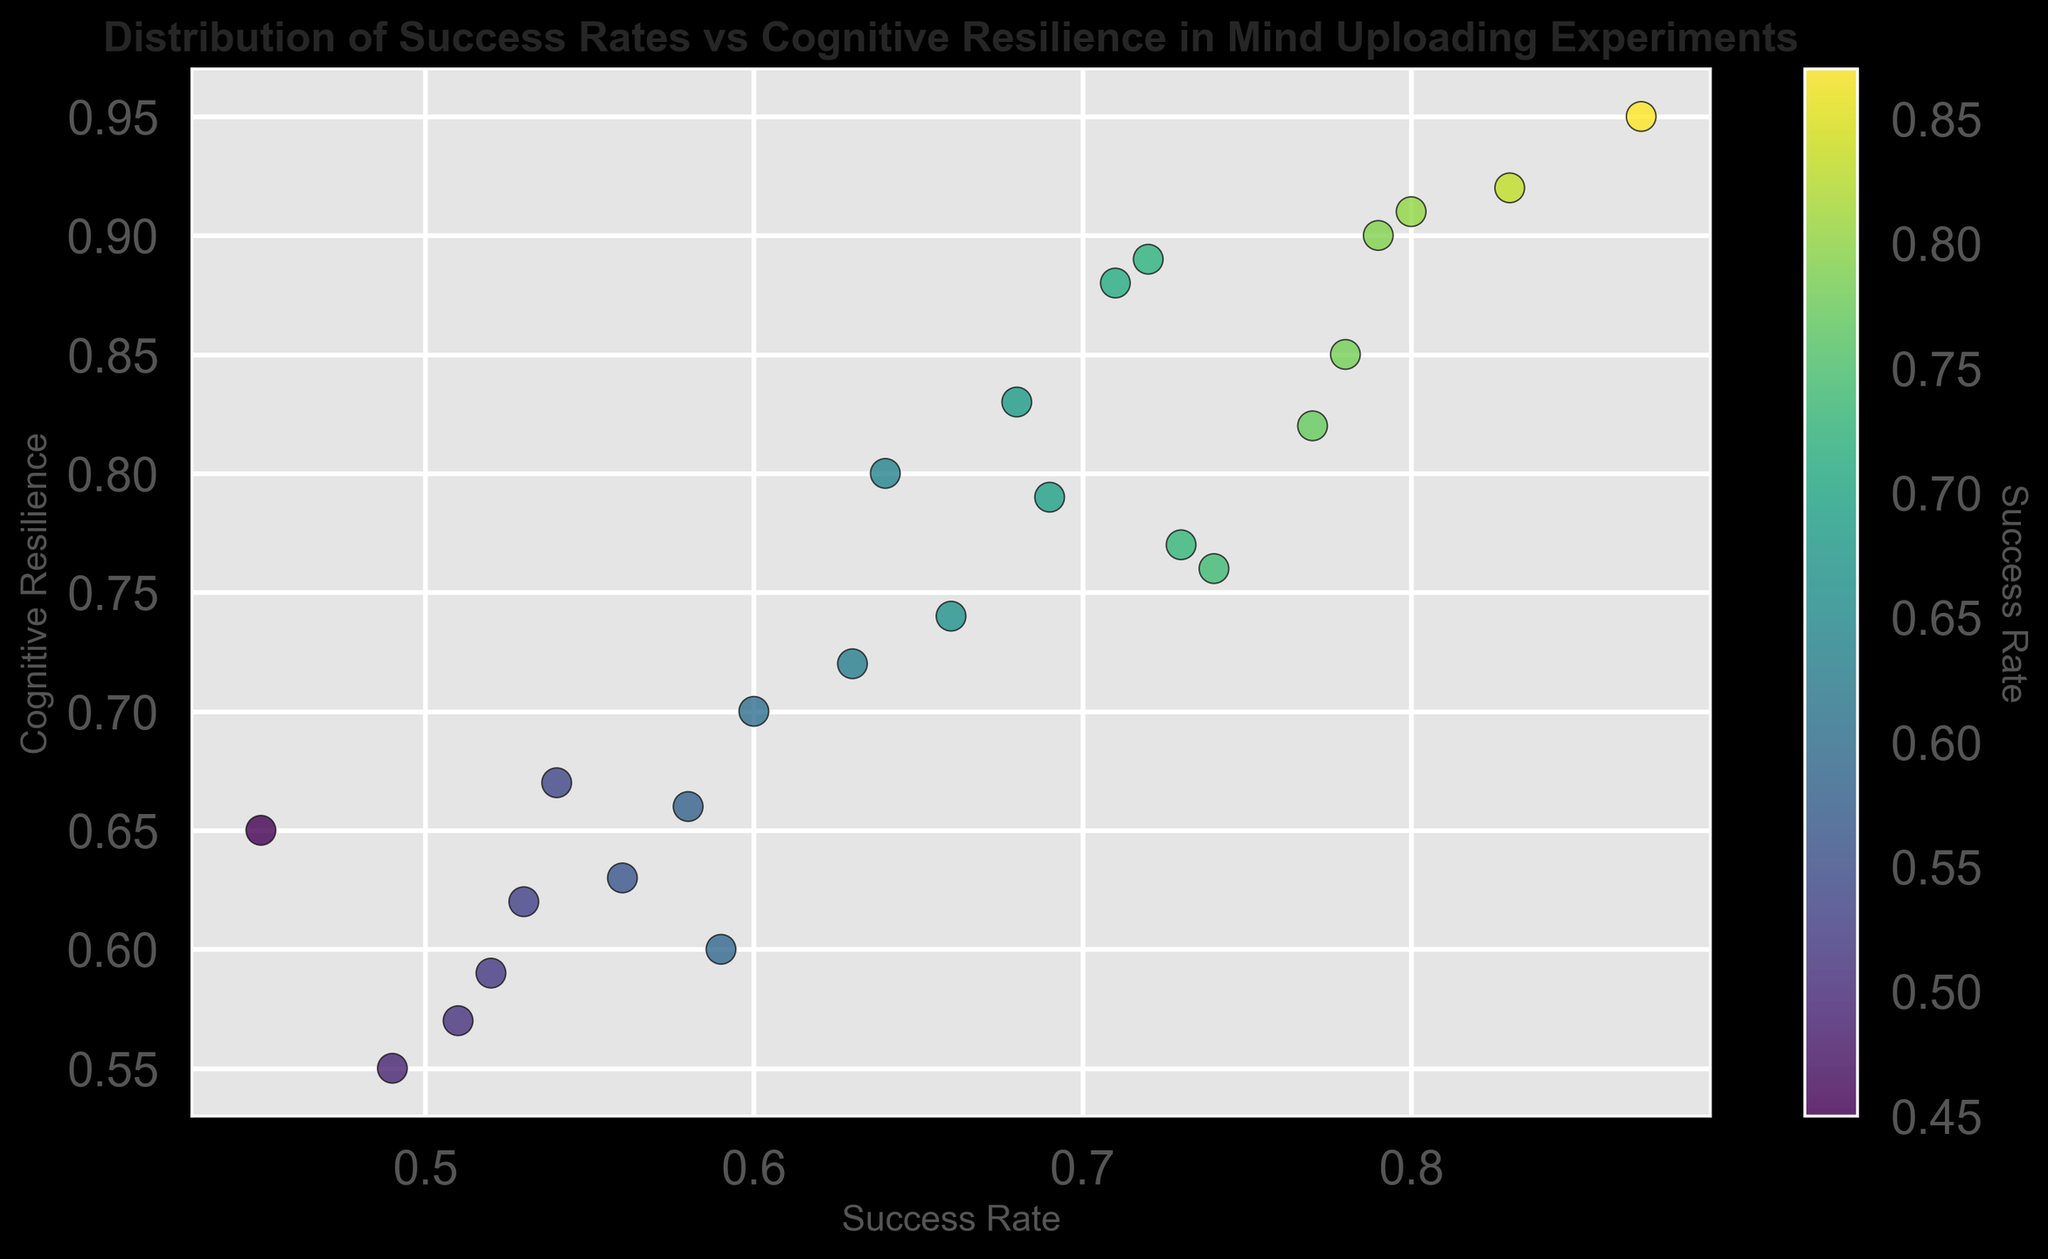What is the highest success rate observed in the experiments? The scatter plot can be inspected to find the maximum point along the Success Rate axis. The highest visible Success Rate is 0.87 from Experiment 5.
Answer: 0.87 Which experiment has the highest cognitive resilience? The scatter plot can be inspected to find the maximum point along the Cognitive Resilience axis. The highest visible Cognitive Resilience is 0.95 from Experiment 5.
Answer: Experiment 5 Is there a visible relationship between success rates and cognitive resilience? Observing the scatter plot, as Success Rate increases, Cognitive Resilience appears to increase as well, suggesting a positive correlation.
Answer: Positive correlation How many experiments have a cognitive resilience above 0.80? By counting the scatter points that lie above 0.80 on the Cognitive Resilience axis, we find that there are 9 experiments.
Answer: 9 Which experiment combines both low success rate and low cognitive resilience, say below 0.60 for both? Finding the scatter points that lie below 0.60 on both axes, Experiment 10 (Success Rate 0.52, Cognitive Resilience 0.59), and Experiment 15 (Success Rate 0.49, Cognitive Resilience 0.55) meet the criteria.
Answer: Experiments 10 and 15 Are there any outliers in terms of success rates and cognitive resilience? Outliers would be points that are quite far from the general trend. Experiment 5 with a high Success Rate (0.87) and Cognitive Resilience (0.95) stands out as an outlier.
Answer: Experiment 5 What is the average success rate for experiments with cognitive resilience above 0.85? Summing the Success Rates of experiments with Cognitive Resilience above 0.85 (Experiments 1, 3, 5, 11, 16, 20, 25), and averaging: (0.78 + 0.71 + 0.87 + 0.80 + 0.72 + 0.83 + 0.79) / 7 ≈ 0.78.
Answer: 0.78 Which experiment has the closest success rate to 0.70? Looking at the scatter plot for points around the 0.70 mark on the Success Rate axis, Experiment 3 has a Success Rate of 0.71, which is closest to 0.70.
Answer: Experiment 3 